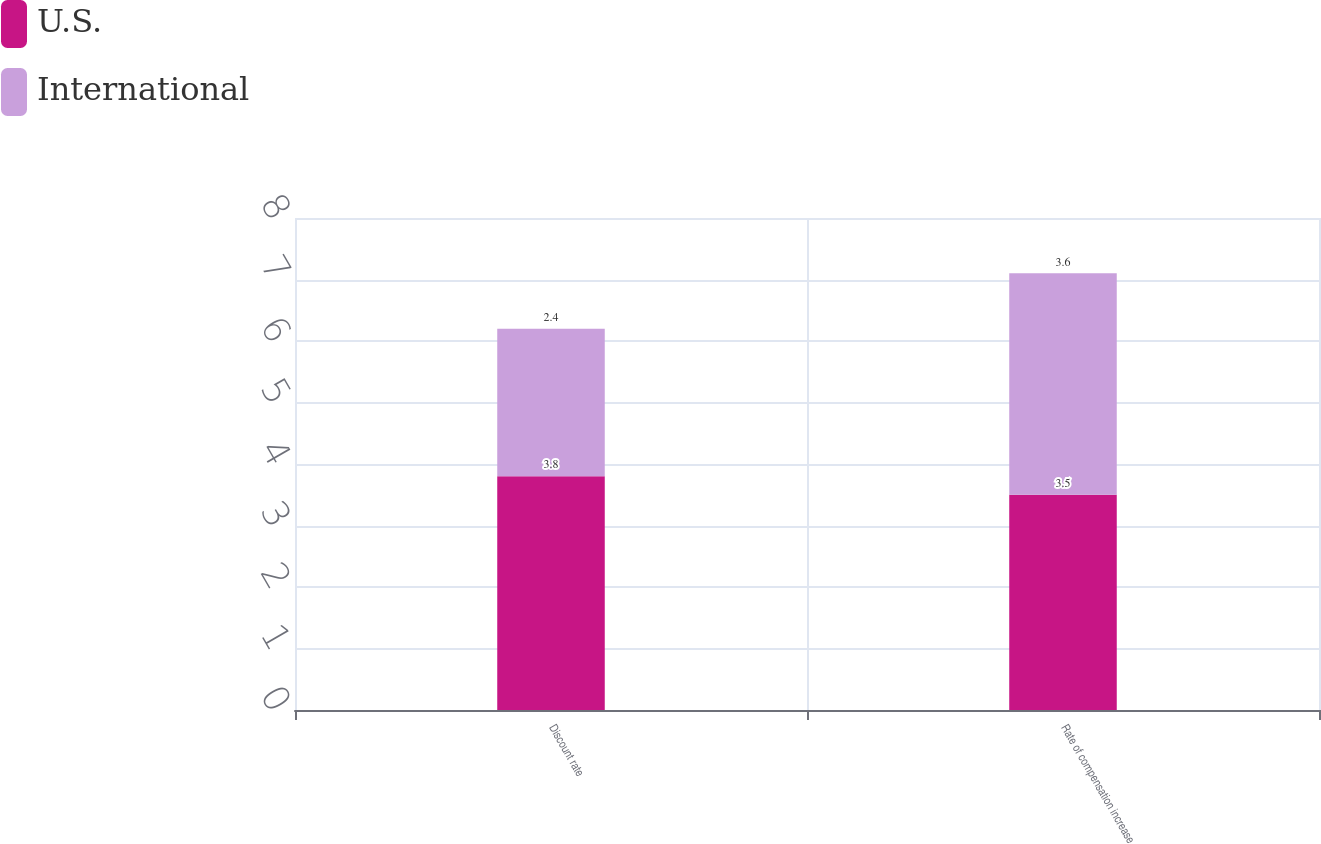<chart> <loc_0><loc_0><loc_500><loc_500><stacked_bar_chart><ecel><fcel>Discount rate<fcel>Rate of compensation increase<nl><fcel>U.S.<fcel>3.8<fcel>3.5<nl><fcel>International<fcel>2.4<fcel>3.6<nl></chart> 